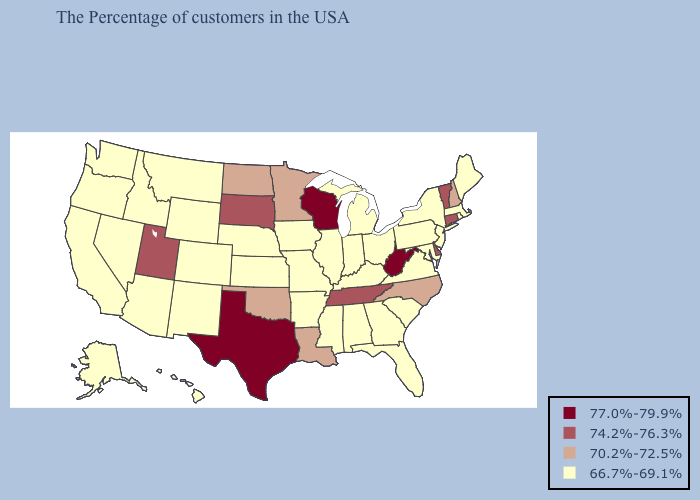What is the value of Arizona?
Be succinct. 66.7%-69.1%. What is the lowest value in states that border New Mexico?
Answer briefly. 66.7%-69.1%. Which states have the highest value in the USA?
Give a very brief answer. West Virginia, Wisconsin, Texas. Which states have the lowest value in the Northeast?
Concise answer only. Maine, Massachusetts, Rhode Island, New York, New Jersey, Pennsylvania. Name the states that have a value in the range 74.2%-76.3%?
Keep it brief. Vermont, Connecticut, Delaware, Tennessee, South Dakota, Utah. Name the states that have a value in the range 66.7%-69.1%?
Answer briefly. Maine, Massachusetts, Rhode Island, New York, New Jersey, Maryland, Pennsylvania, Virginia, South Carolina, Ohio, Florida, Georgia, Michigan, Kentucky, Indiana, Alabama, Illinois, Mississippi, Missouri, Arkansas, Iowa, Kansas, Nebraska, Wyoming, Colorado, New Mexico, Montana, Arizona, Idaho, Nevada, California, Washington, Oregon, Alaska, Hawaii. What is the value of Delaware?
Be succinct. 74.2%-76.3%. Among the states that border Alabama , which have the lowest value?
Write a very short answer. Florida, Georgia, Mississippi. Does Ohio have the highest value in the USA?
Write a very short answer. No. What is the lowest value in the South?
Give a very brief answer. 66.7%-69.1%. What is the value of Mississippi?
Give a very brief answer. 66.7%-69.1%. What is the lowest value in the USA?
Answer briefly. 66.7%-69.1%. Among the states that border New Hampshire , which have the lowest value?
Concise answer only. Maine, Massachusetts. Which states have the lowest value in the MidWest?
Short answer required. Ohio, Michigan, Indiana, Illinois, Missouri, Iowa, Kansas, Nebraska. 